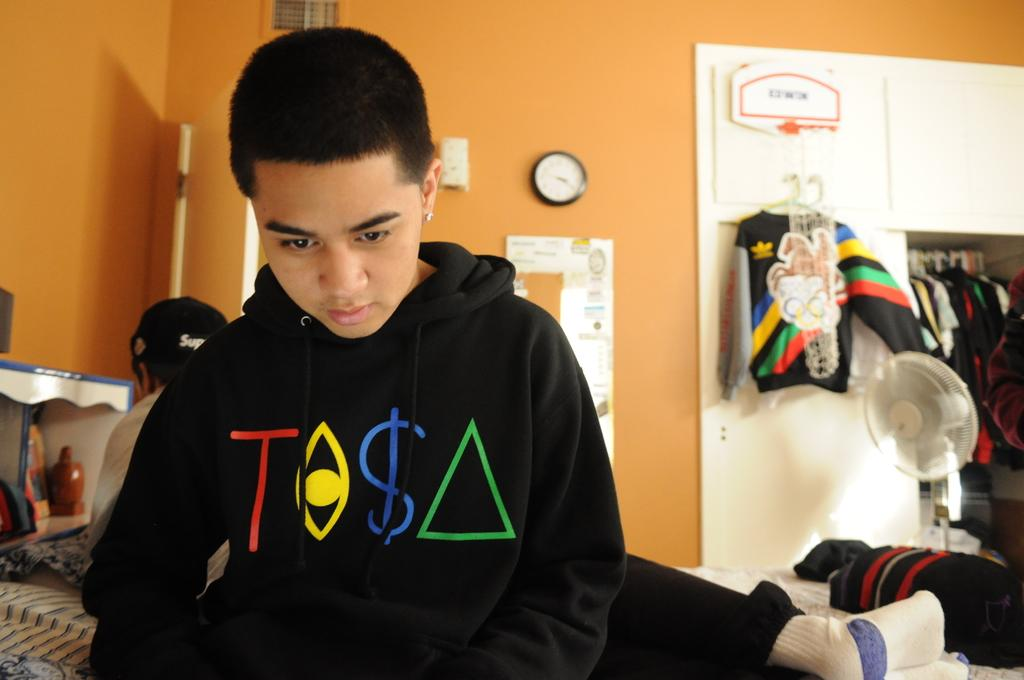<image>
Describe the image concisely. Two boys are sitting on a bed and one has a hoodie that says Tosa. 